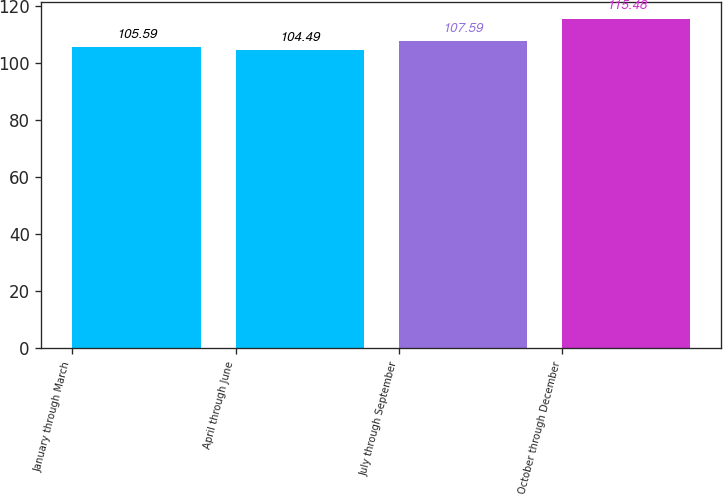Convert chart to OTSL. <chart><loc_0><loc_0><loc_500><loc_500><bar_chart><fcel>January through March<fcel>April through June<fcel>July through September<fcel>October through December<nl><fcel>105.59<fcel>104.49<fcel>107.59<fcel>115.48<nl></chart> 